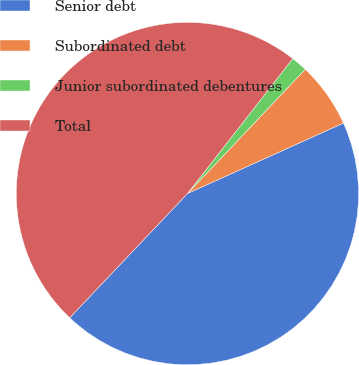Convert chart to OTSL. <chart><loc_0><loc_0><loc_500><loc_500><pie_chart><fcel>Senior debt<fcel>Subordinated debt<fcel>Junior subordinated debentures<fcel>Total<nl><fcel>43.83%<fcel>6.17%<fcel>1.53%<fcel>48.47%<nl></chart> 